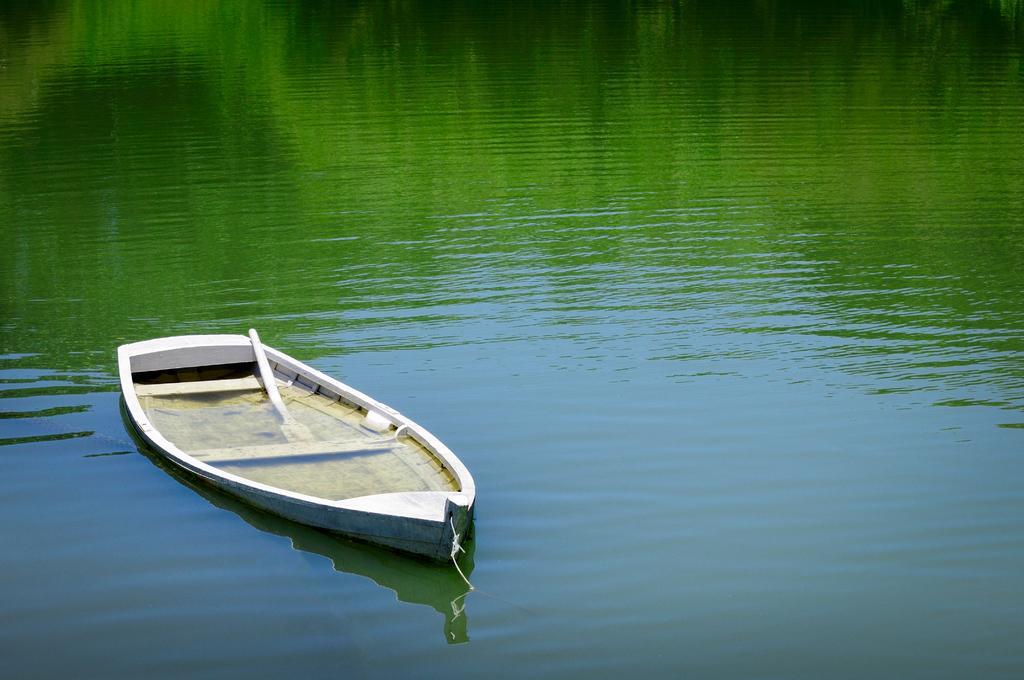Describe this image in one or two sentences. In this picture we can see a boat with paddle on the water. 